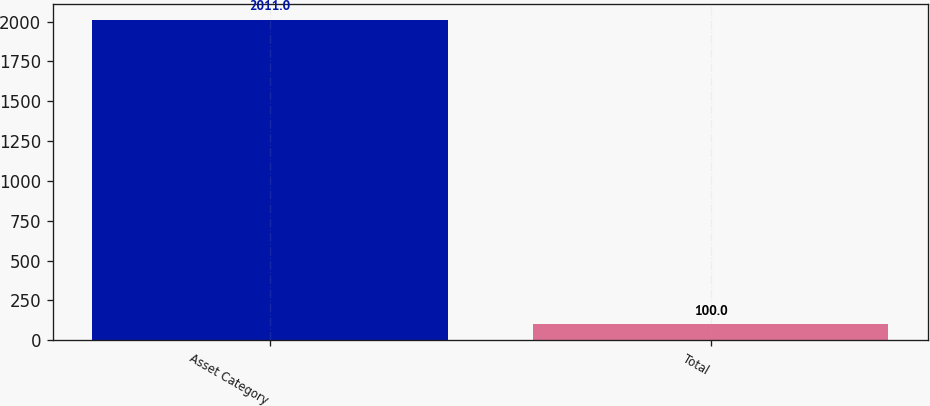Convert chart. <chart><loc_0><loc_0><loc_500><loc_500><bar_chart><fcel>Asset Category<fcel>Total<nl><fcel>2011<fcel>100<nl></chart> 